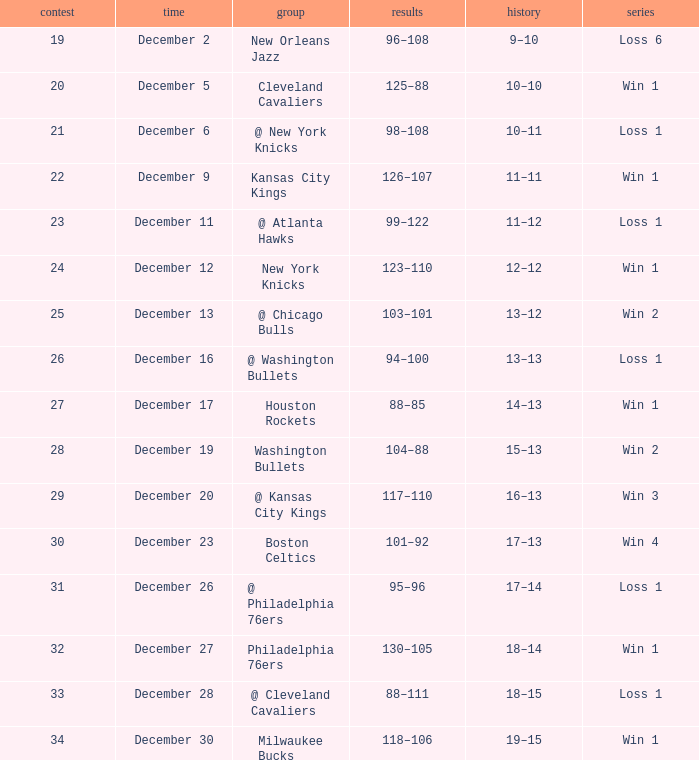What is the run on december 30? Win 1. 